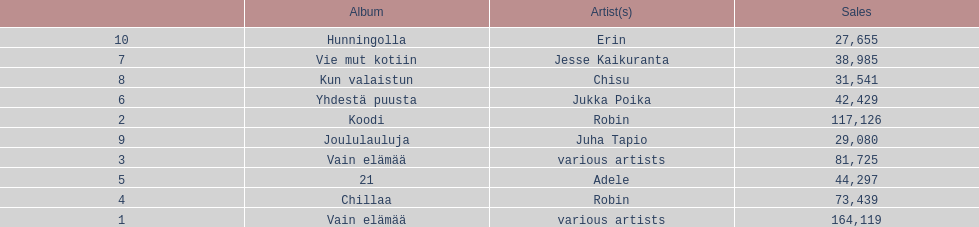Which was the last album to sell over 100,000 records? Koodi. 